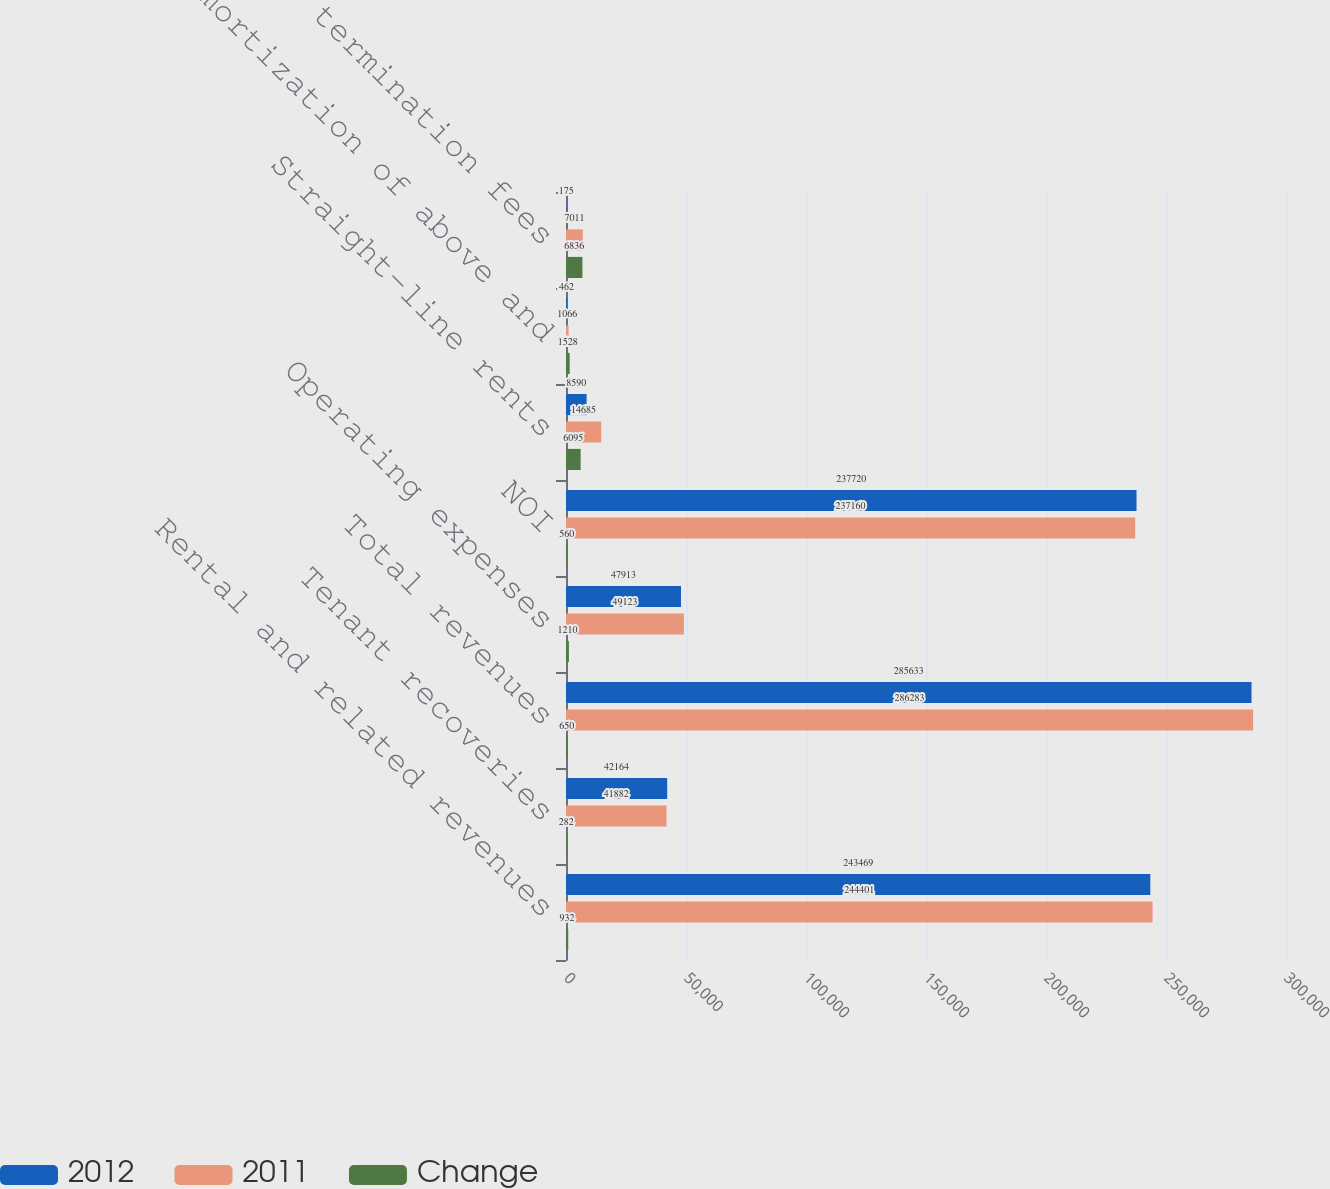Convert chart to OTSL. <chart><loc_0><loc_0><loc_500><loc_500><stacked_bar_chart><ecel><fcel>Rental and related revenues<fcel>Tenant recoveries<fcel>Total revenues<fcel>Operating expenses<fcel>NOI<fcel>Straight-line rents<fcel>Amortization of above and<fcel>Lease termination fees<nl><fcel>2012<fcel>243469<fcel>42164<fcel>285633<fcel>47913<fcel>237720<fcel>8590<fcel>462<fcel>175<nl><fcel>2011<fcel>244401<fcel>41882<fcel>286283<fcel>49123<fcel>237160<fcel>14685<fcel>1066<fcel>7011<nl><fcel>Change<fcel>932<fcel>282<fcel>650<fcel>1210<fcel>560<fcel>6095<fcel>1528<fcel>6836<nl></chart> 